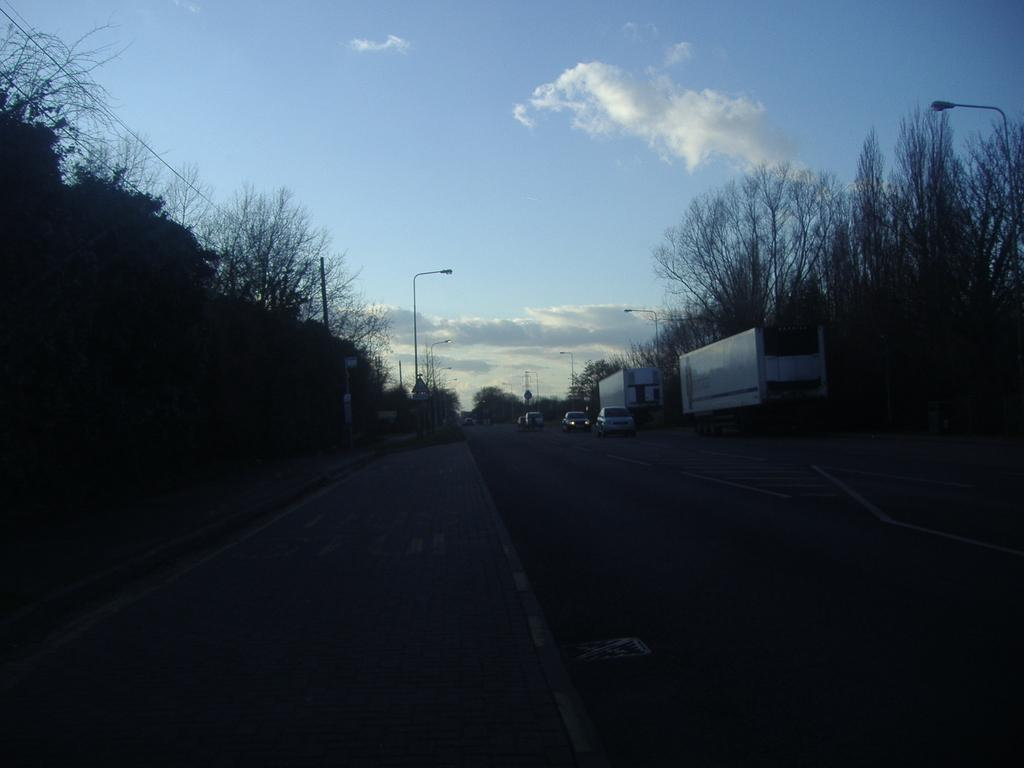At what time of day was the image taken? The image was taken during the evening. What type of natural elements can be seen in the image? There are many trees in the image. What type of artificial lighting is present in the image? There are light poles in the image. What is visible at the top of the image? The sky is visible at the top of the image. What can be observed in the sky in the image? There are clouds in the sky. What type of drain is visible in the image? There is no drain present in the image. What type of apparel is the tree wearing in the image? Trees do not wear apparel, so this question cannot be answered. 